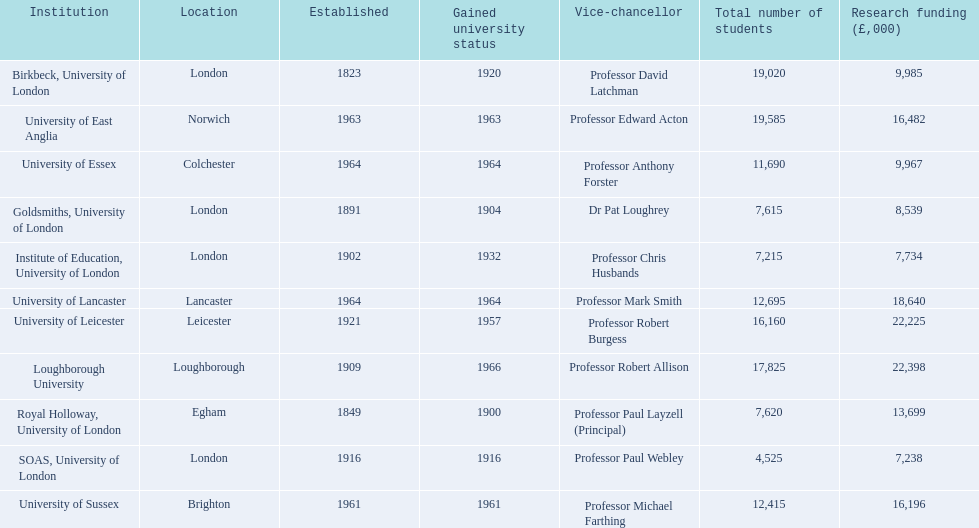What are the names of all the institutions? Birkbeck, University of London, University of East Anglia, University of Essex, Goldsmiths, University of London, Institute of Education, University of London, University of Lancaster, University of Leicester, Loughborough University, Royal Holloway, University of London, SOAS, University of London, University of Sussex. In what range of years were these institutions established? 1823, 1963, 1964, 1891, 1902, 1964, 1921, 1909, 1849, 1916, 1961. In what range of years did these institutions gain university status? 1920, 1963, 1964, 1904, 1932, 1964, 1957, 1966, 1900, 1916, 1961. What institution most recently gained university status? Loughborough University. 